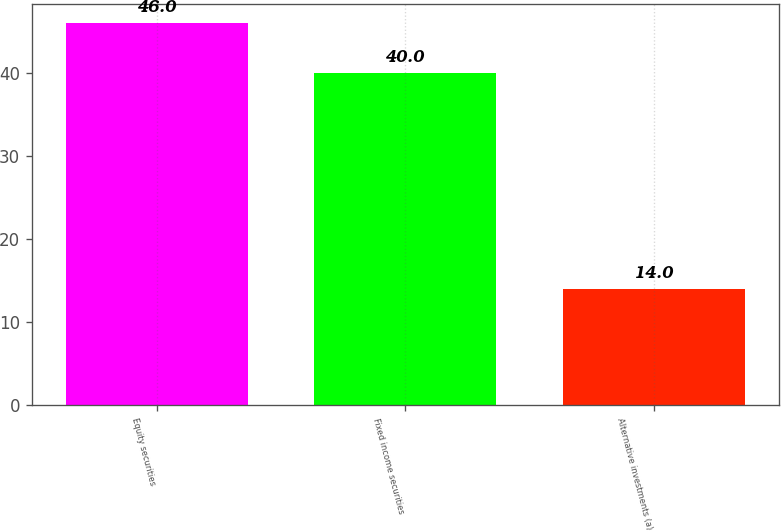Convert chart to OTSL. <chart><loc_0><loc_0><loc_500><loc_500><bar_chart><fcel>Equity securities<fcel>Fixed income securities<fcel>Alternative investments (a)<nl><fcel>46<fcel>40<fcel>14<nl></chart> 